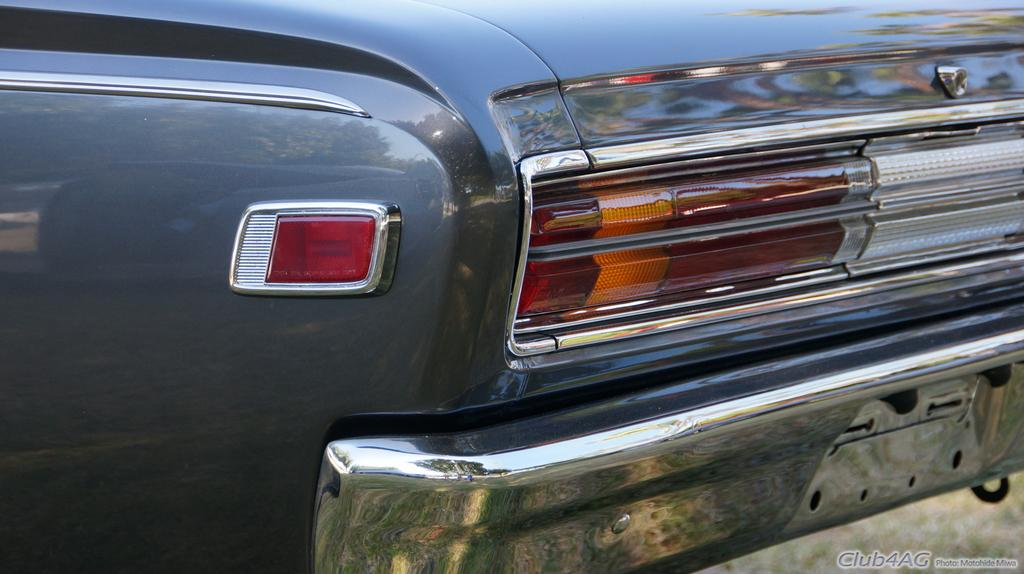Where was the image taken? The image was taken outdoors. What can be seen in the image besides the outdoor setting? There is a car in the image. What is the color of the car? The car is gray in color. What type of ship can be seen in the image? There is no ship present in the image; it features an outdoor setting with a gray car. 